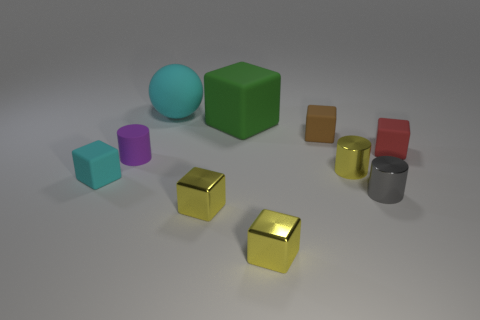Subtract all tiny brown blocks. How many blocks are left? 5 Subtract all cyan cubes. How many cubes are left? 5 Subtract all red blocks. Subtract all green cylinders. How many blocks are left? 5 Subtract all cylinders. How many objects are left? 7 Subtract all tiny yellow metal balls. Subtract all small brown things. How many objects are left? 9 Add 3 red matte blocks. How many red matte blocks are left? 4 Add 8 brown matte blocks. How many brown matte blocks exist? 9 Subtract 1 red blocks. How many objects are left? 9 